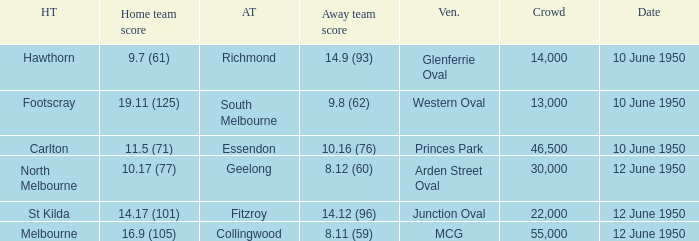What was the crowd when the VFL played MCG? 55000.0. 